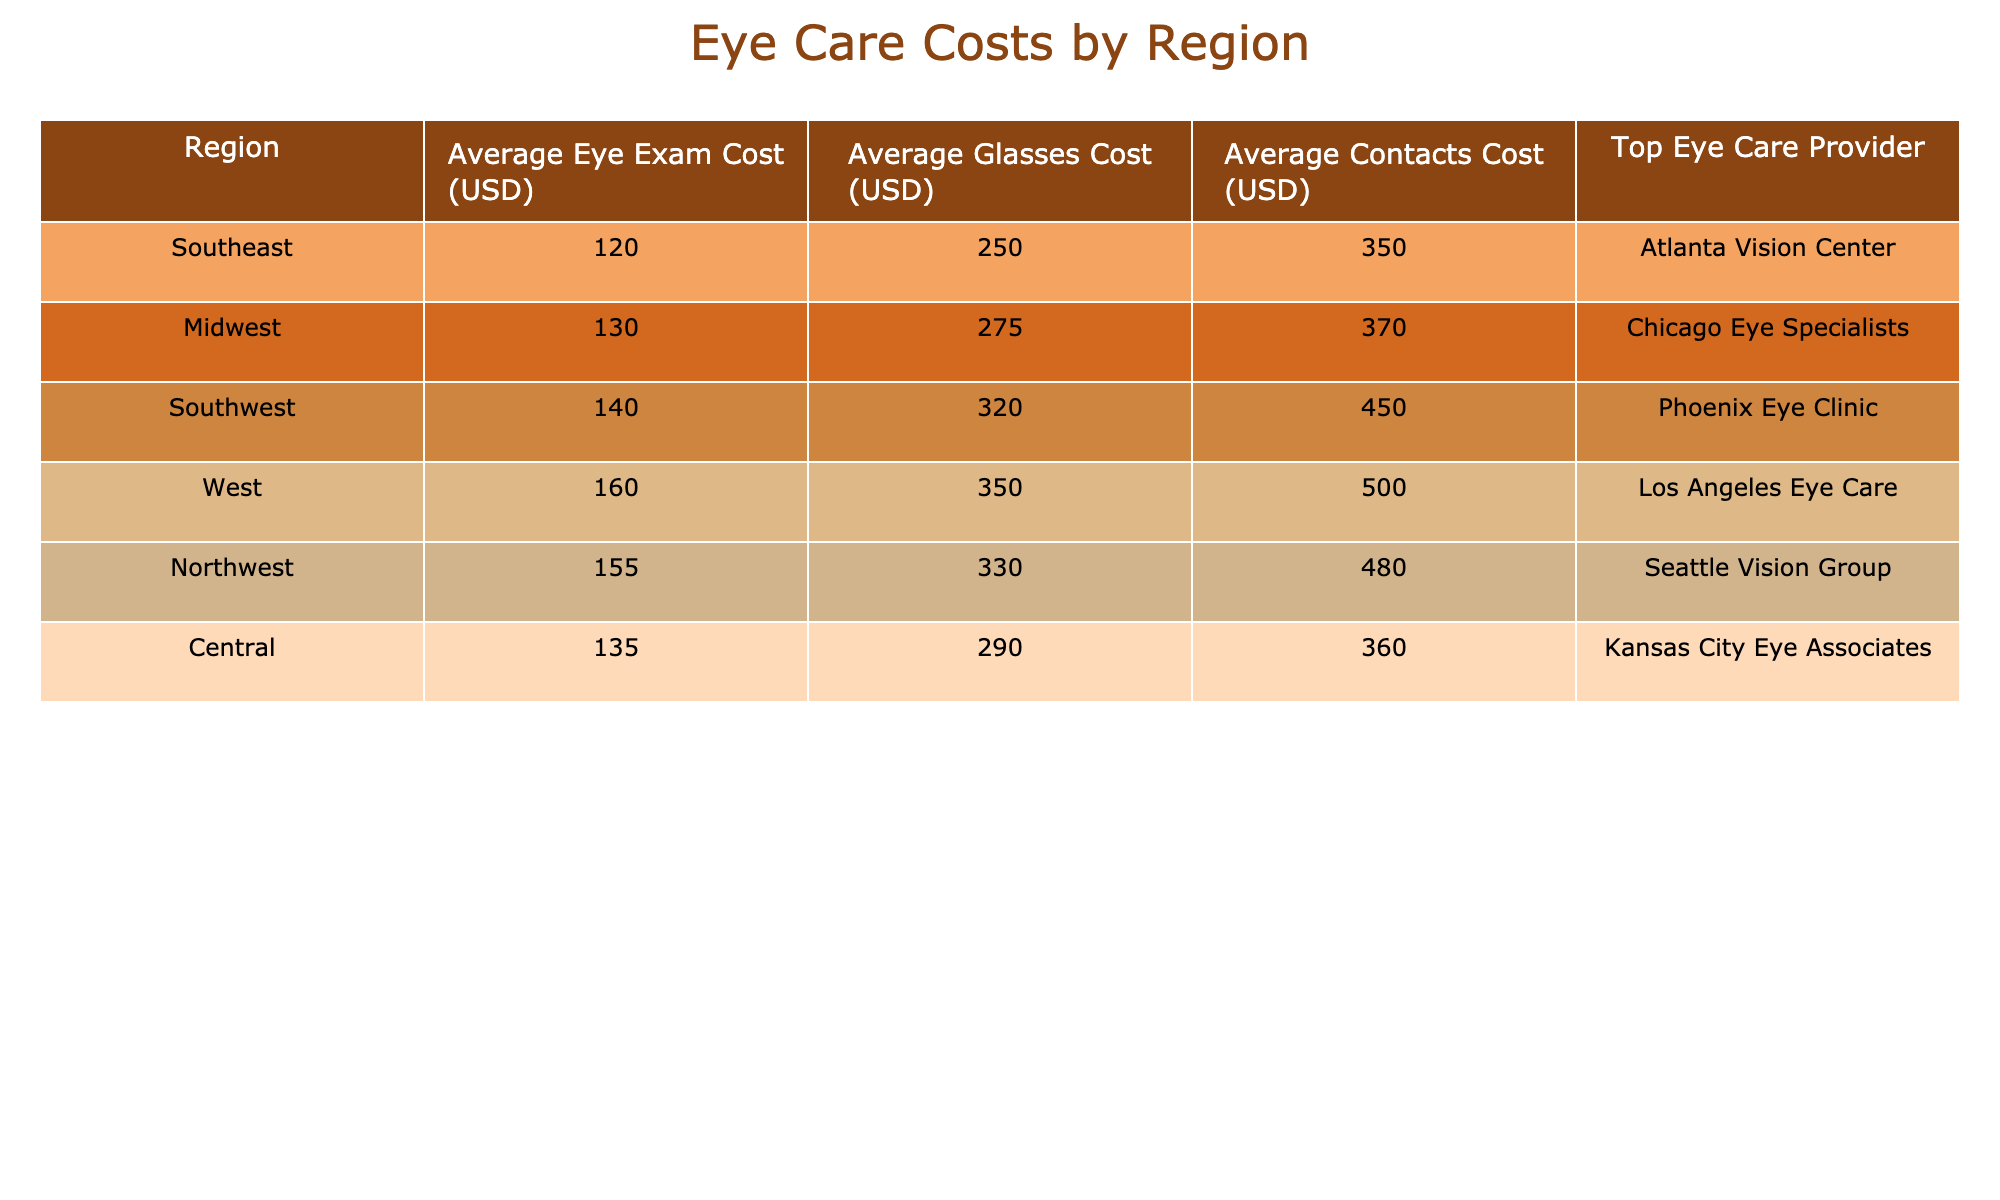What is the average eye exam cost in the Southwest region? From the table, the average eye exam cost listed for the Southwest region is 140 USD.
Answer: 140 USD Which region has the highest average cost for glasses? The table indicates that the West region has the highest average cost for glasses at 350 USD compared to other regions.
Answer: West What is the average cost of contacts in the Midwest and Central regions combined? The average cost of contacts in the Midwest is 370 USD and in the Central region it is 360 USD. Adding these gives 370 + 360 = 730 USD. To find the average, divide by 2, resulting in 730/2 = 365 USD.
Answer: 365 USD Is the average eye exam cost higher in the Northwest than in the Southeast? The average eye exam cost in the Northwest is 155 USD, while in the Southeast it is 120 USD. Since 155 is greater than 120, the answer is yes.
Answer: Yes What is the difference between average glass cost in the South and the average contact cost in the Southwest? The average glasses cost in the South is 320 USD, and the average contacts cost in the Southwest is 450 USD. The difference is calculated as 450 - 320 = 130 USD.
Answer: 130 USD Which region is associated with the top eye care provider Atlanta Vision Center? The table shows that Atlanta Vision Center is listed as the top eye care provider for the Southeast region.
Answer: Southeast What region has the lowest average cost for an eye exam? Observing the data, the Southeast region has the lowest average eye exam cost of 120 USD compared to all other regions.
Answer: Southeast If someone lives in the Northwest, how much would they spend on average for glasses and contacts together? In the Northwest, the average glasses cost is 330 USD, and the average contacts cost is 480 USD. Adding these costs gives 330 + 480 = 810 USD.
Answer: 810 USD 